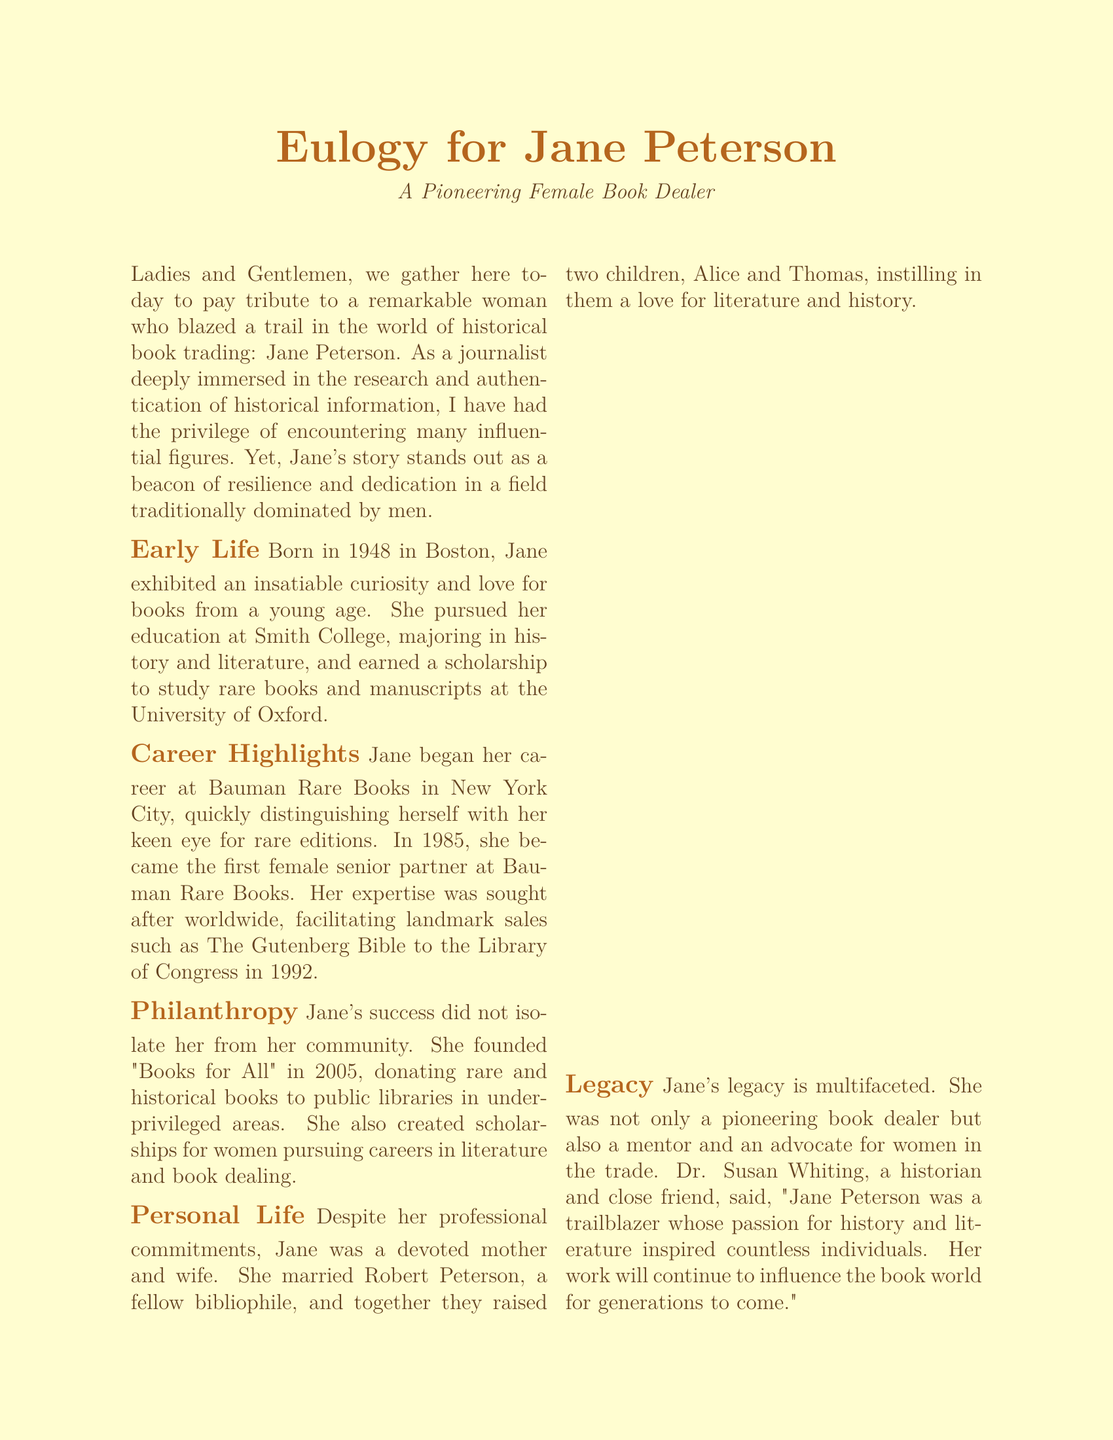What year was Jane Peterson born? The document states Jane was born in 1948.
Answer: 1948 Where did Jane study rare books and manuscripts? According to the document, Jane earned a scholarship to study rare books at the University of Oxford.
Answer: University of Oxford What significant sale did Jane facilitate in 1992? The document mentions that she facilitated the sale of The Gutenberg Bible to the Library of Congress.
Answer: The Gutenberg Bible What organization did Jane found in 2005? The document specifies that she founded "Books for All" to donate books to public libraries.
Answer: Books for All Who described Jane as a trailblazer? The document cites Dr. Susan Whiting, a historian and close friend, as the one who described her as a trailblazer.
Answer: Dr. Susan Whiting What was Jane's role at Bauman Rare Books in 1985? The document notes that she became the first female senior partner at Bauman Rare Books in 1985.
Answer: First female senior partner What was Jane's approach to her community despite her success? The document states that her success did not isolate her as she was actively involved in philanthropy.
Answer: Philanthropy How many children did Jane raise? The document indicates that Jane and her husband raised two children.
Answer: Two children 